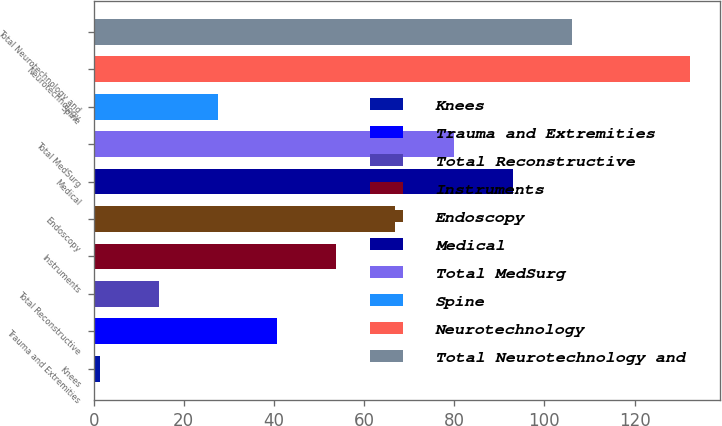Convert chart. <chart><loc_0><loc_0><loc_500><loc_500><bar_chart><fcel>Knees<fcel>Trauma and Extremities<fcel>Total Reconstructive<fcel>Instruments<fcel>Endoscopy<fcel>Medical<fcel>Total MedSurg<fcel>Spine<fcel>Neurotechnology<fcel>Total Neurotechnology and<nl><fcel>1.5<fcel>40.74<fcel>14.58<fcel>53.82<fcel>66.9<fcel>93.06<fcel>79.98<fcel>27.66<fcel>132.3<fcel>106.14<nl></chart> 